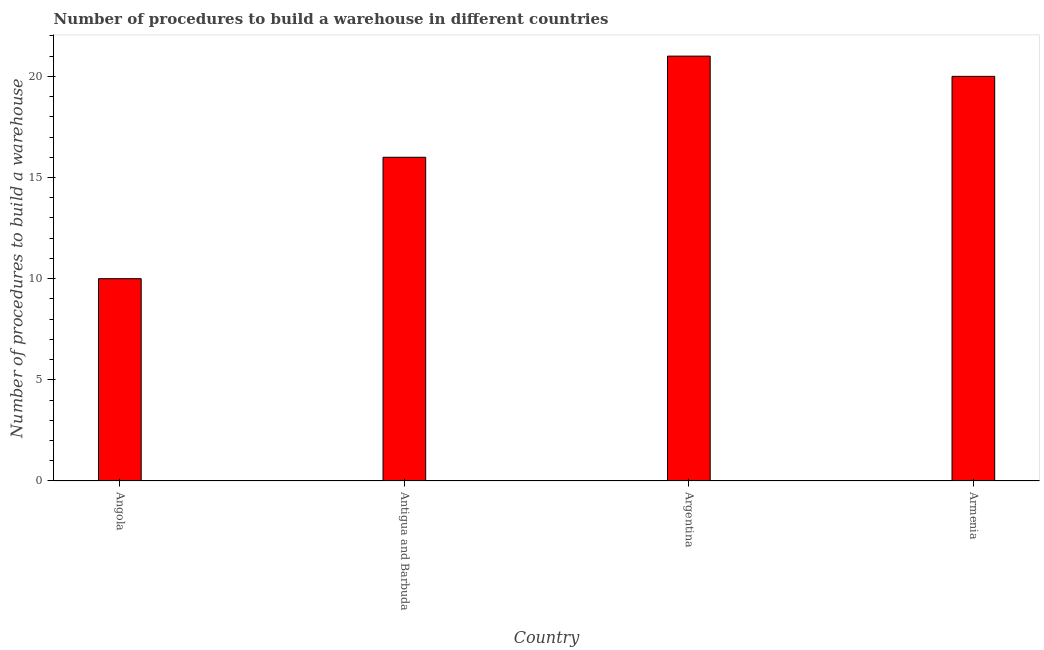What is the title of the graph?
Offer a very short reply. Number of procedures to build a warehouse in different countries. What is the label or title of the Y-axis?
Provide a short and direct response. Number of procedures to build a warehouse. What is the number of procedures to build a warehouse in Armenia?
Make the answer very short. 20. Across all countries, what is the maximum number of procedures to build a warehouse?
Your answer should be compact. 21. Across all countries, what is the minimum number of procedures to build a warehouse?
Provide a succinct answer. 10. In which country was the number of procedures to build a warehouse minimum?
Keep it short and to the point. Angola. What is the sum of the number of procedures to build a warehouse?
Offer a terse response. 67. What is the average number of procedures to build a warehouse per country?
Provide a short and direct response. 16.75. Is the difference between the number of procedures to build a warehouse in Argentina and Armenia greater than the difference between any two countries?
Provide a short and direct response. No. Is the sum of the number of procedures to build a warehouse in Angola and Antigua and Barbuda greater than the maximum number of procedures to build a warehouse across all countries?
Provide a short and direct response. Yes. In how many countries, is the number of procedures to build a warehouse greater than the average number of procedures to build a warehouse taken over all countries?
Ensure brevity in your answer.  2. How many bars are there?
Offer a terse response. 4. Are all the bars in the graph horizontal?
Give a very brief answer. No. How many countries are there in the graph?
Ensure brevity in your answer.  4. What is the difference between two consecutive major ticks on the Y-axis?
Provide a succinct answer. 5. What is the Number of procedures to build a warehouse of Argentina?
Offer a terse response. 21. What is the difference between the Number of procedures to build a warehouse in Angola and Antigua and Barbuda?
Ensure brevity in your answer.  -6. What is the difference between the Number of procedures to build a warehouse in Angola and Argentina?
Your answer should be compact. -11. What is the difference between the Number of procedures to build a warehouse in Angola and Armenia?
Your answer should be compact. -10. What is the difference between the Number of procedures to build a warehouse in Antigua and Barbuda and Armenia?
Give a very brief answer. -4. What is the ratio of the Number of procedures to build a warehouse in Angola to that in Argentina?
Make the answer very short. 0.48. What is the ratio of the Number of procedures to build a warehouse in Antigua and Barbuda to that in Argentina?
Offer a terse response. 0.76. 